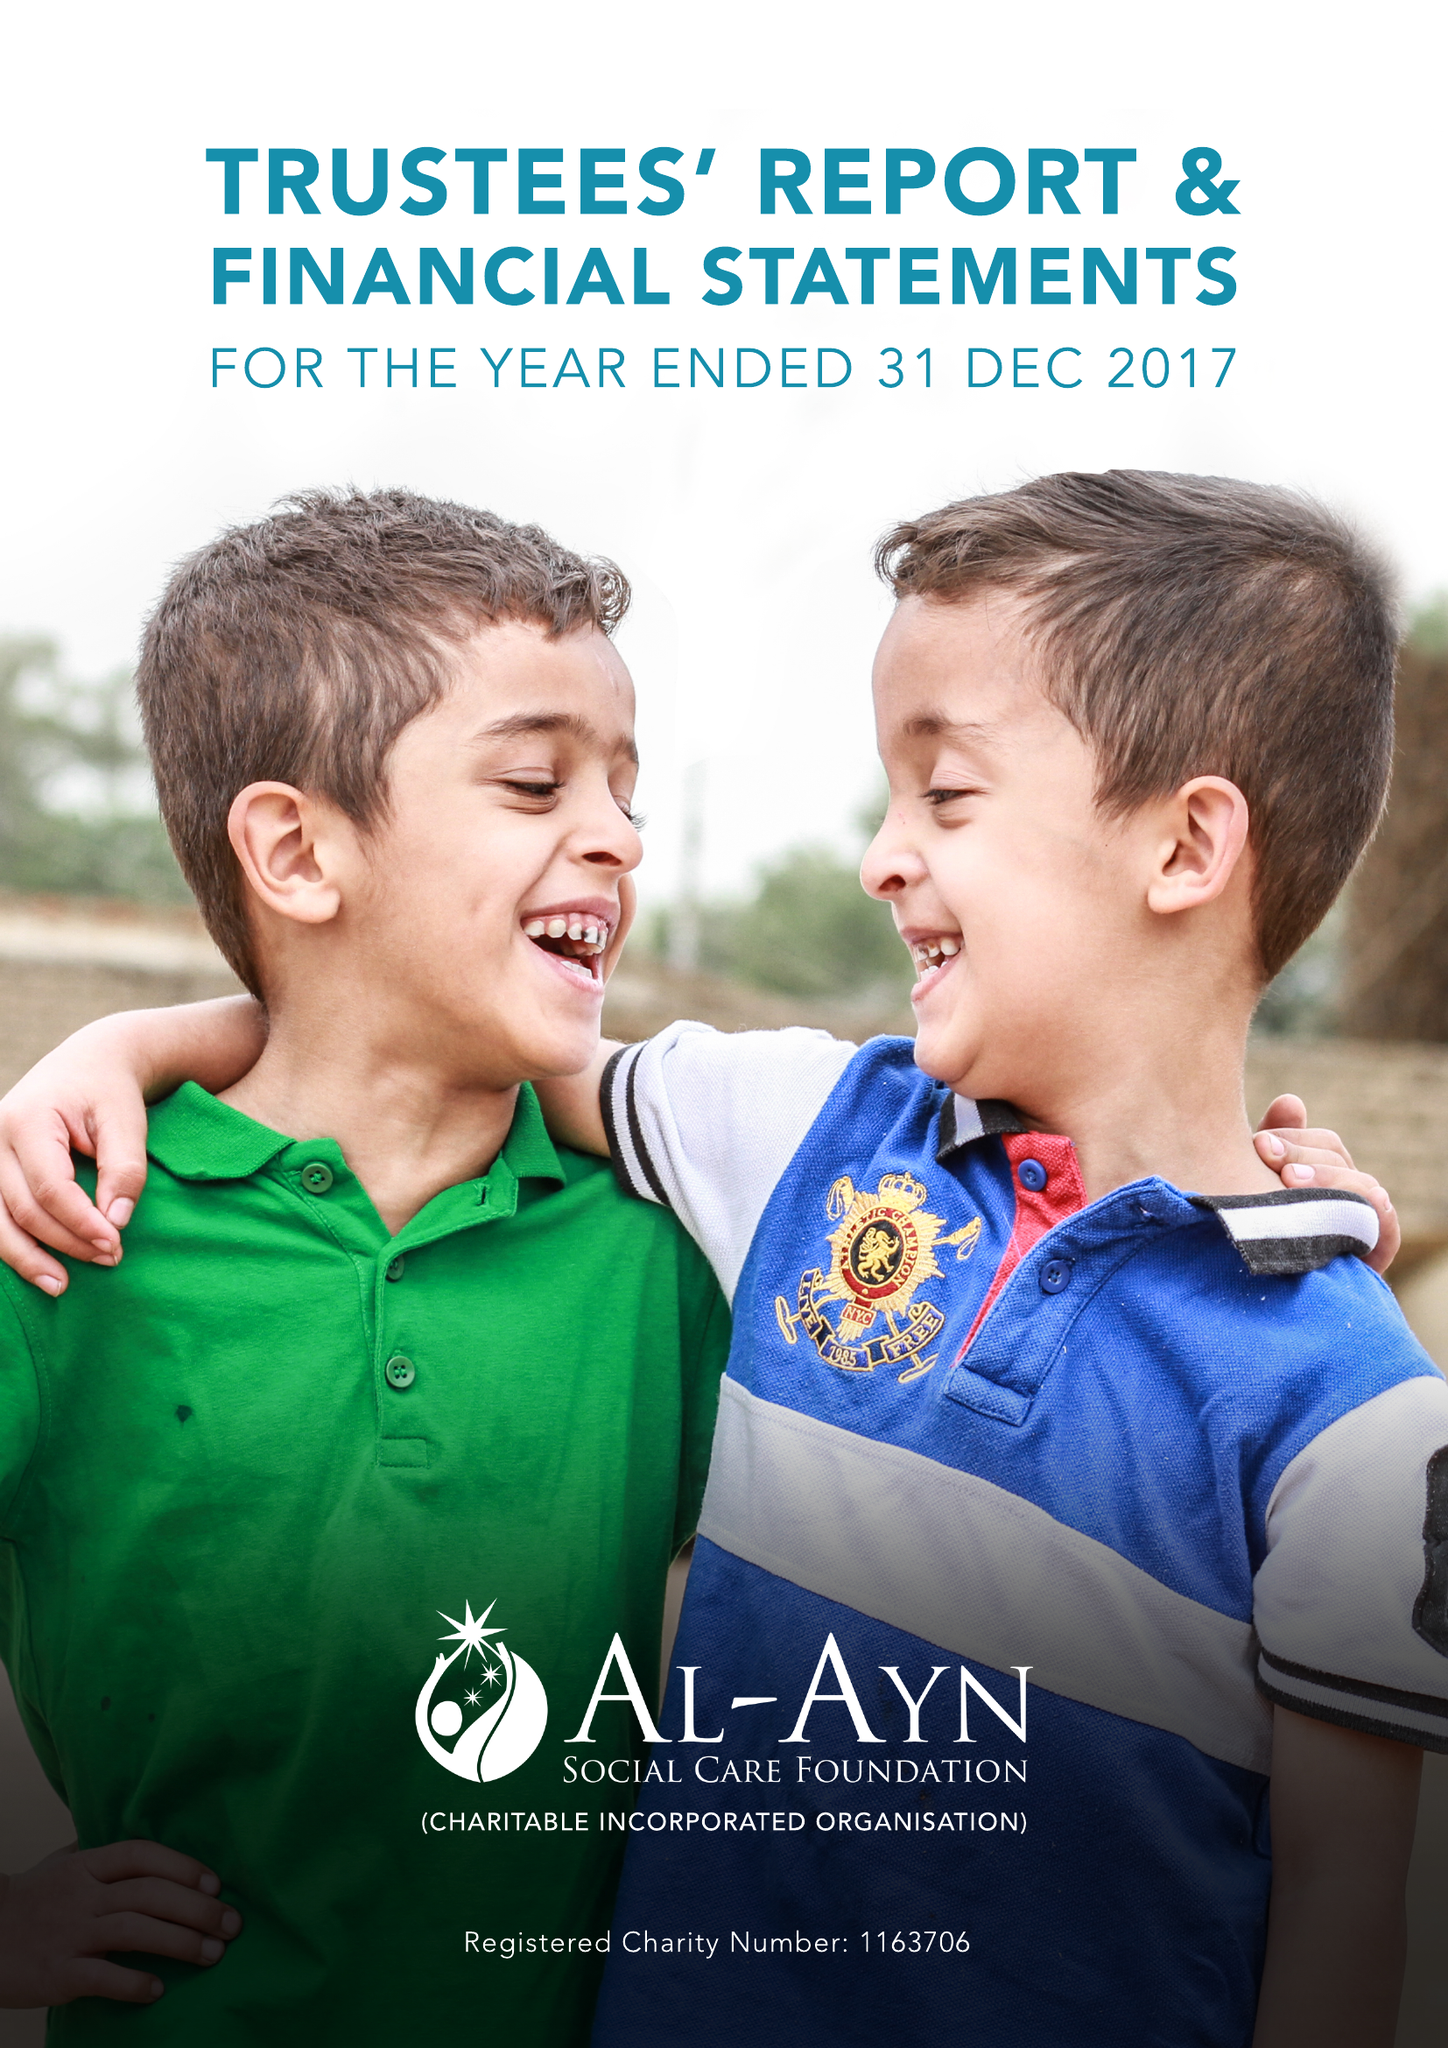What is the value for the address__post_town?
Answer the question using a single word or phrase. LONDON 